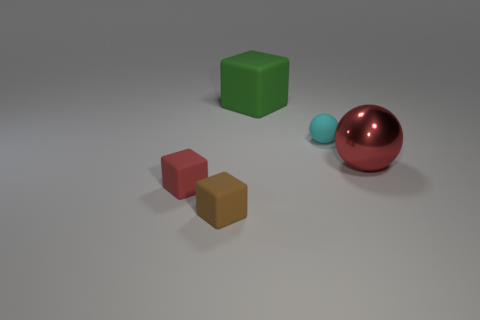Is the number of red matte things that are on the right side of the large sphere less than the number of small balls in front of the cyan rubber sphere?
Your answer should be compact. No. How many small shiny balls are there?
Keep it short and to the point. 0. Are there any other things that have the same material as the big green block?
Keep it short and to the point. Yes. There is a big green thing that is the same shape as the tiny red matte object; what is it made of?
Your answer should be compact. Rubber. Are there fewer rubber things that are left of the small cyan ball than small rubber cubes?
Keep it short and to the point. No. There is a matte thing to the right of the big green matte object; is its shape the same as the large green matte object?
Provide a short and direct response. No. Is there anything else that has the same color as the tiny ball?
Ensure brevity in your answer.  No. The green block that is made of the same material as the cyan object is what size?
Ensure brevity in your answer.  Large. What is the red thing that is right of the small matte thing on the right side of the big object that is on the left side of the cyan rubber object made of?
Your answer should be very brief. Metal. Are there fewer tiny purple shiny spheres than small cyan balls?
Provide a short and direct response. Yes. 